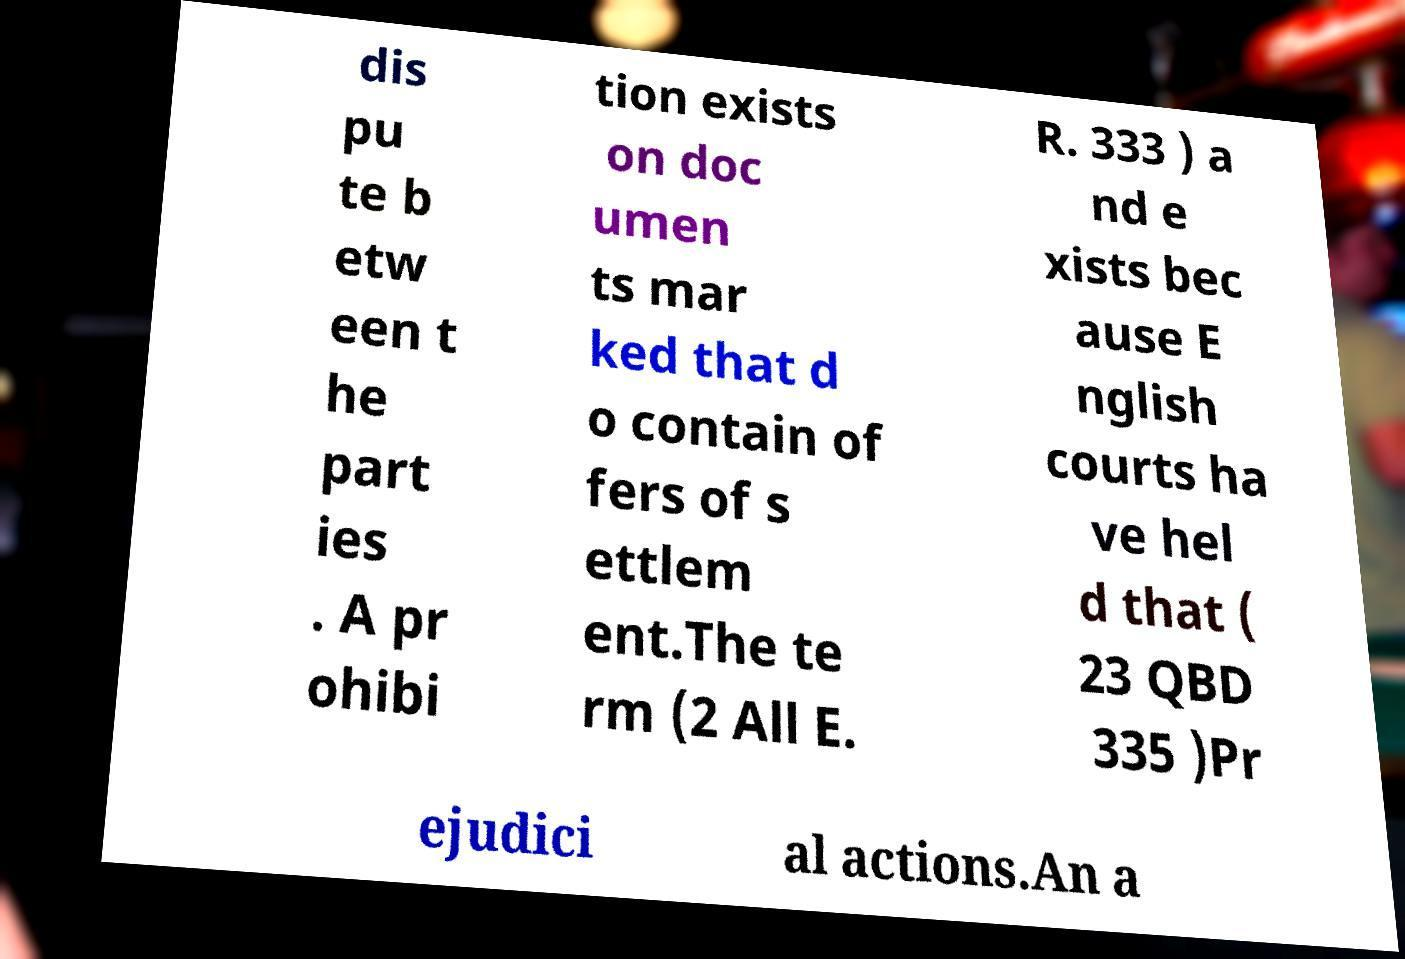Please read and relay the text visible in this image. What does it say? dis pu te b etw een t he part ies . A pr ohibi tion exists on doc umen ts mar ked that d o contain of fers of s ettlem ent.The te rm (2 All E. R. 333 ) a nd e xists bec ause E nglish courts ha ve hel d that ( 23 QBD 335 )Pr ejudici al actions.An a 